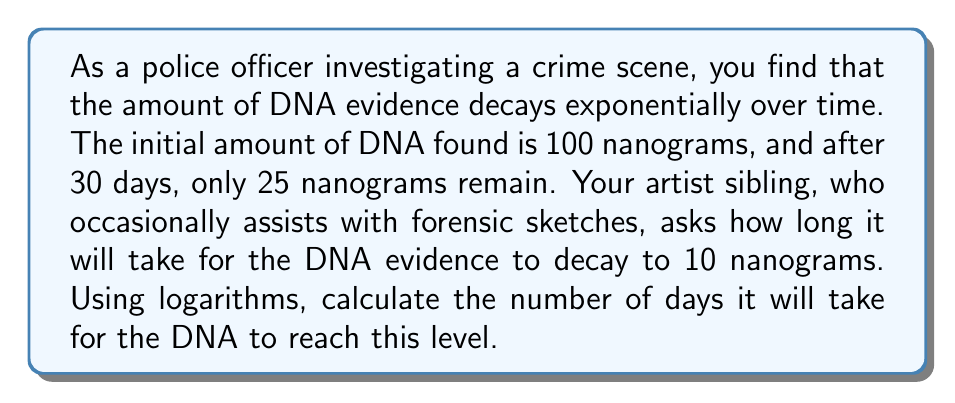Show me your answer to this math problem. Let's approach this step-by-step using logarithms:

1) The exponential decay formula is:
   $A(t) = A_0 \cdot e^{-kt}$
   Where $A(t)$ is the amount at time $t$, $A_0$ is the initial amount, $k$ is the decay constant, and $t$ is time.

2) We need to find $k$ first. We know:
   $A_0 = 100$ ng
   $A(30) = 25$ ng
   $t = 30$ days

3) Plugging into the formula:
   $25 = 100 \cdot e^{-30k}$

4) Dividing both sides by 100:
   $0.25 = e^{-30k}$

5) Taking natural log of both sides:
   $\ln(0.25) = -30k$

6) Solving for $k$:
   $k = -\frac{\ln(0.25)}{30} \approx 0.0462$

7) Now, we want to find $t$ when $A(t) = 10$ ng. Using the formula again:
   $10 = 100 \cdot e^{-0.0462t}$

8) Dividing both sides by 100:
   $0.1 = e^{-0.0462t}$

9) Taking natural log of both sides:
   $\ln(0.1) = -0.0462t$

10) Solving for $t$:
    $t = -\frac{\ln(0.1)}{0.0462} \approx 49.78$ days
Answer: $49.78$ days 